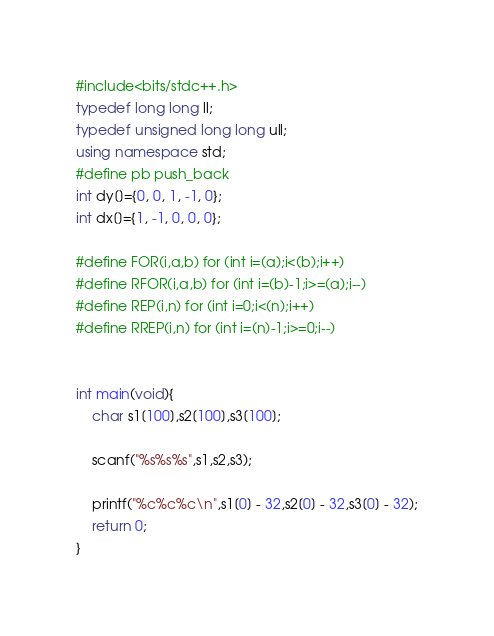Convert code to text. <code><loc_0><loc_0><loc_500><loc_500><_C++_>#include<bits/stdc++.h>
typedef long long ll;
typedef unsigned long long ull;
using namespace std;
#define pb push_back
int dy[]={0, 0, 1, -1, 0};
int dx[]={1, -1, 0, 0, 0};

#define FOR(i,a,b) for (int i=(a);i<(b);i++)
#define RFOR(i,a,b) for (int i=(b)-1;i>=(a);i--)
#define REP(i,n) for (int i=0;i<(n);i++)
#define RREP(i,n) for (int i=(n)-1;i>=0;i--)


int main(void){
    char s1[100],s2[100],s3[100];

    scanf("%s%s%s",s1,s2,s3);

    printf("%c%c%c\n",s1[0] - 32,s2[0] - 32,s3[0] - 32);
    return 0;
}</code> 